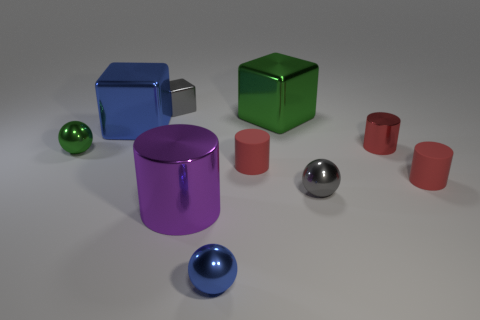Subtract all red cylinders. How many were subtracted if there are1red cylinders left? 2 Subtract all brown cubes. How many red cylinders are left? 3 Subtract all brown cylinders. Subtract all green spheres. How many cylinders are left? 4 Subtract all spheres. How many objects are left? 7 Subtract 0 gray cylinders. How many objects are left? 10 Subtract all big blue shiny cubes. Subtract all red rubber cylinders. How many objects are left? 7 Add 9 small blue things. How many small blue things are left? 10 Add 4 green blocks. How many green blocks exist? 5 